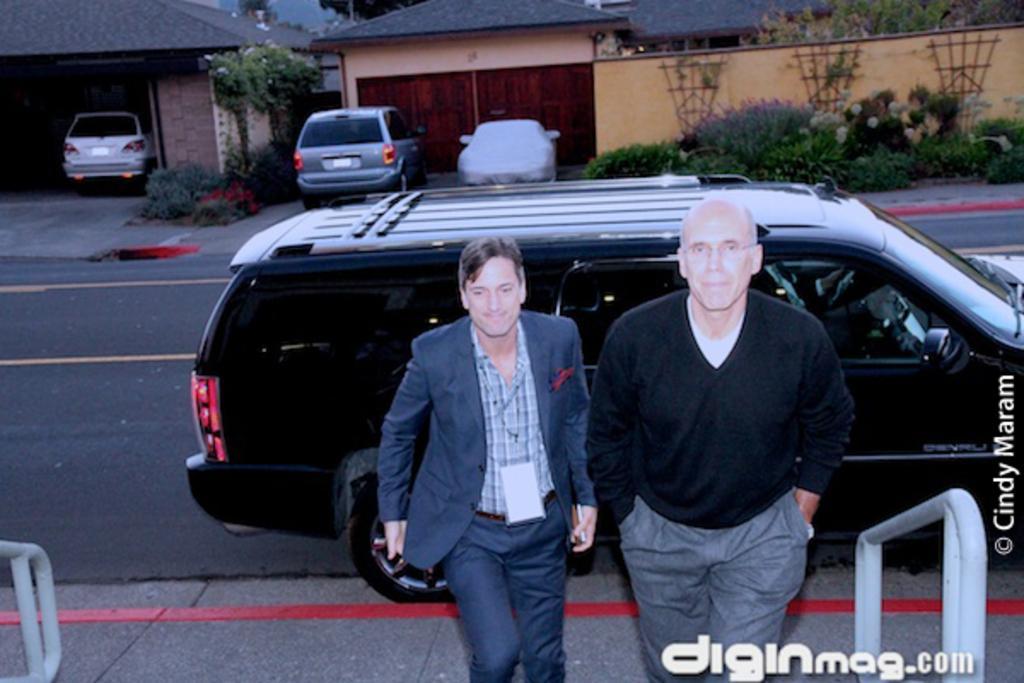In one or two sentences, can you explain what this image depicts? There are two men standing at the bottom of this image. We can see vehicles and a road in the middle of this image. There are houses and plants present at the top of this image. There is a watermark on the right side of this image and at the bottom of this image as well. 